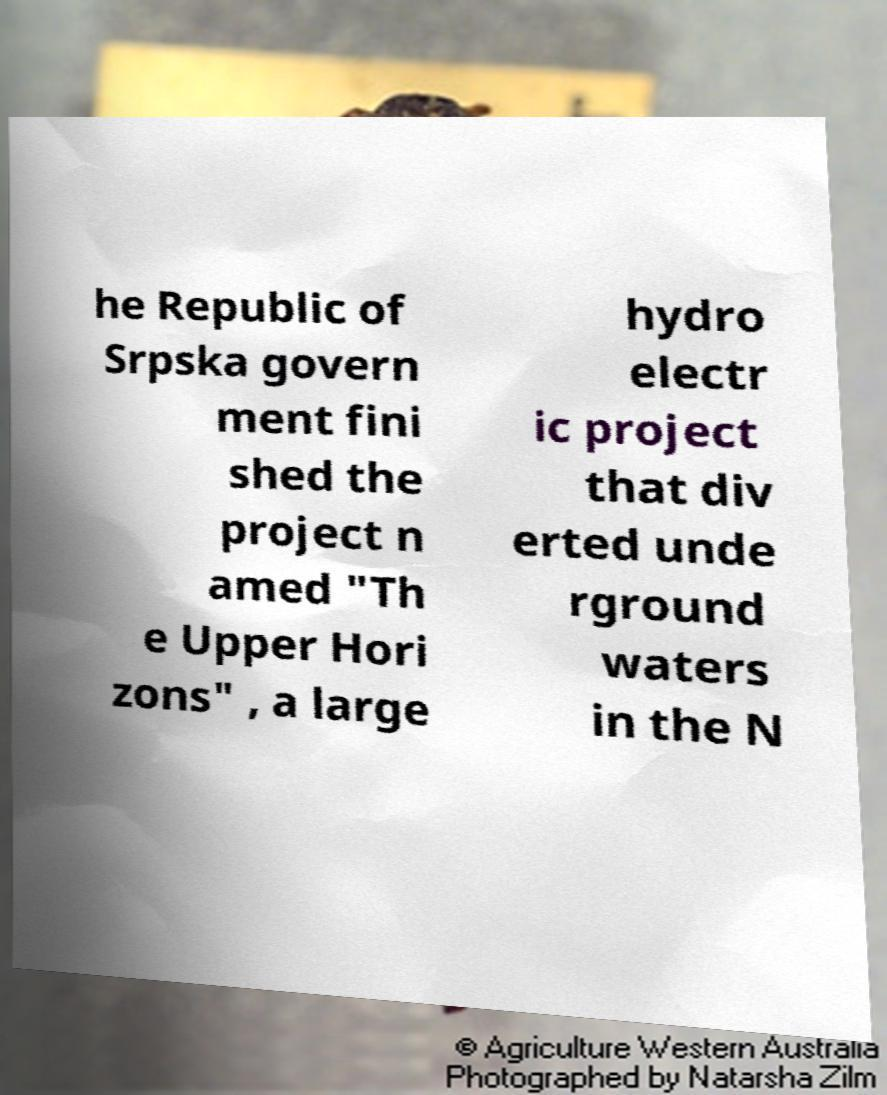Can you read and provide the text displayed in the image?This photo seems to have some interesting text. Can you extract and type it out for me? he Republic of Srpska govern ment fini shed the project n amed "Th e Upper Hori zons" , a large hydro electr ic project that div erted unde rground waters in the N 